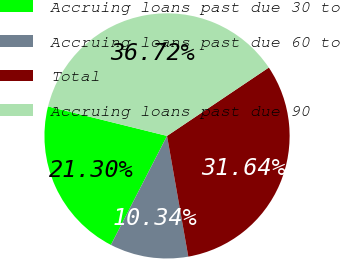Convert chart to OTSL. <chart><loc_0><loc_0><loc_500><loc_500><pie_chart><fcel>Accruing loans past due 30 to<fcel>Accruing loans past due 60 to<fcel>Total<fcel>Accruing loans past due 90<nl><fcel>21.3%<fcel>10.34%<fcel>31.64%<fcel>36.72%<nl></chart> 